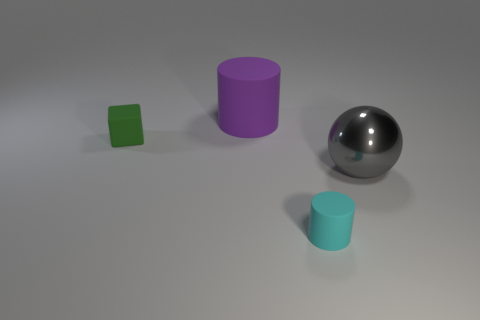Add 2 small rubber cylinders. How many objects exist? 6 Subtract 2 cylinders. How many cylinders are left? 0 Add 1 tiny objects. How many tiny objects exist? 3 Subtract 0 purple blocks. How many objects are left? 4 Subtract all blocks. How many objects are left? 3 Subtract all green cylinders. Subtract all brown blocks. How many cylinders are left? 2 Subtract all gray metal balls. Subtract all big metal balls. How many objects are left? 2 Add 1 small matte blocks. How many small matte blocks are left? 2 